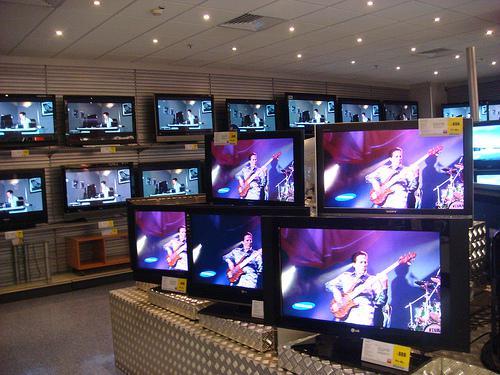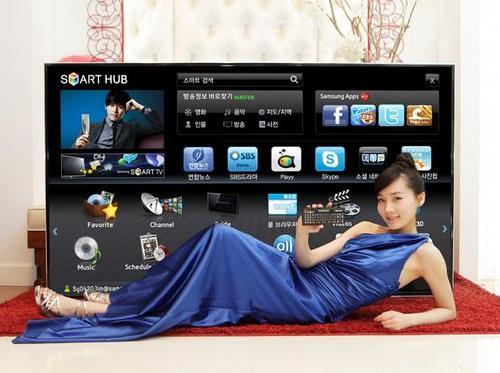The first image is the image on the left, the second image is the image on the right. For the images displayed, is the sentence "A single person is shown with some televisions." factually correct? Answer yes or no. Yes. The first image is the image on the left, the second image is the image on the right. For the images shown, is this caption "An image shows at least one man standing by a screen display." true? Answer yes or no. No. 